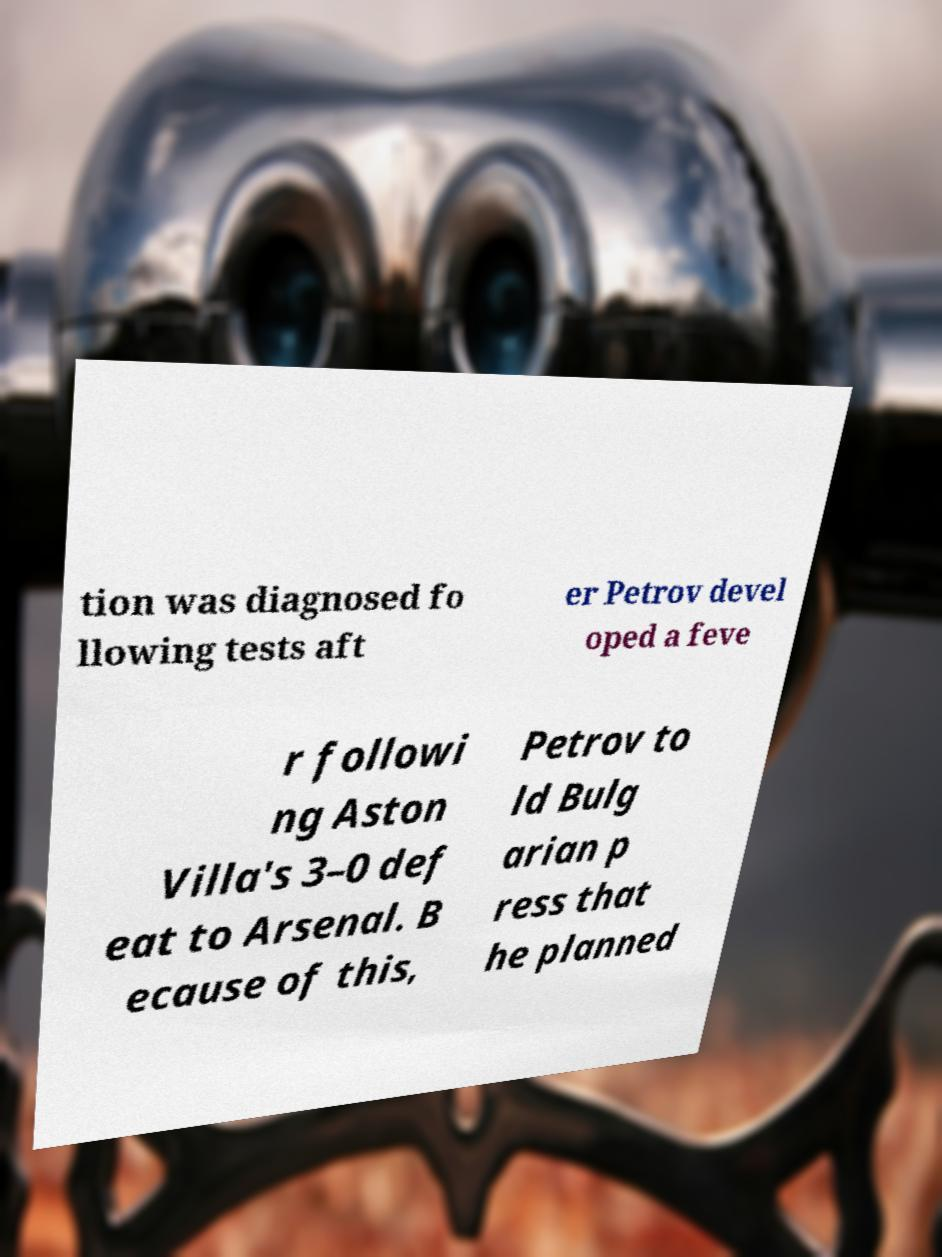I need the written content from this picture converted into text. Can you do that? tion was diagnosed fo llowing tests aft er Petrov devel oped a feve r followi ng Aston Villa's 3–0 def eat to Arsenal. B ecause of this, Petrov to ld Bulg arian p ress that he planned 